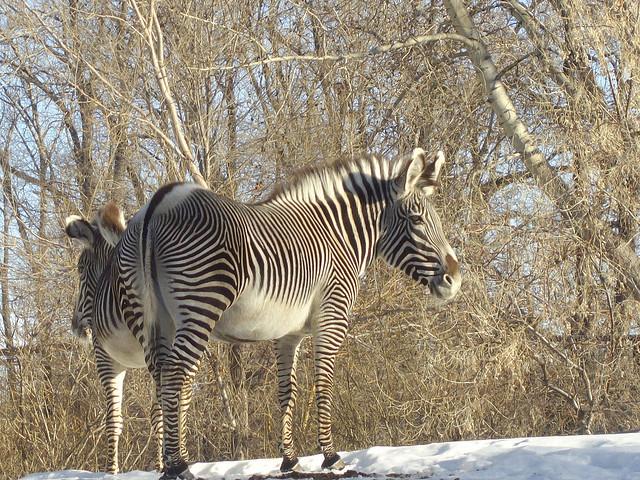How many zebras are there in this picture?
Give a very brief answer. 2. How many zebras are not standing?
Short answer required. 0. What is on the ground?
Concise answer only. Snow. Are the zebras facing the same direction?
Be succinct. No. How many zebras are there?
Short answer required. 2. 